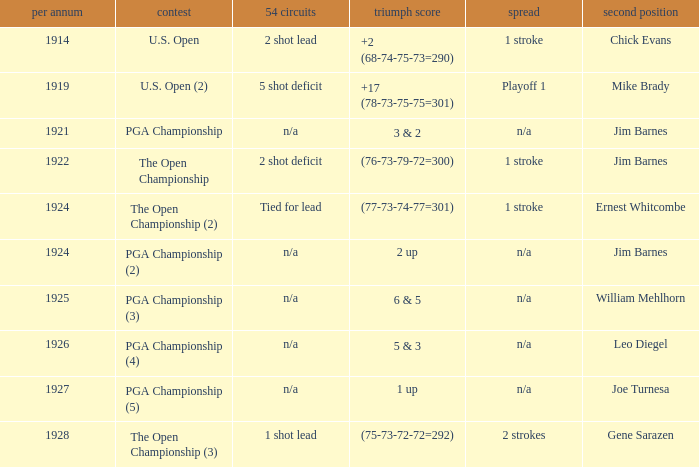WHAT YEAR WAS IT WHEN THE SCORE WAS 3 & 2? 1921.0. 